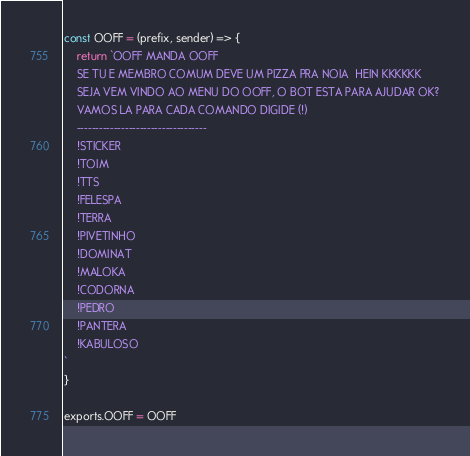Convert code to text. <code><loc_0><loc_0><loc_500><loc_500><_JavaScript_>const OOFF = (prefix, sender) => {
	return `OOFF MANDA OOFF 
	SE TU E MEMBRO COMUM DEVE UM PIZZA PRA NOIA  HEIN KKKKKK
	SEJA VEM VINDO AO MENU DO OOFF, O BOT ESTA PARA AJUDAR OK?
	VAMOS LA PARA CADA COMANDO DIGIDE (!)
	-----------------------------------
	!STICKER
	!TOIM
	!TTS
	!FELESPA
	!TERRA
	!PIVETINHO
	!DOMINAT
	!MALOKA
	!CODORNA
    !PEDRO
    !PANTERA
	!KABULOSO
`
}

exports.OOFF = OOFF</code> 